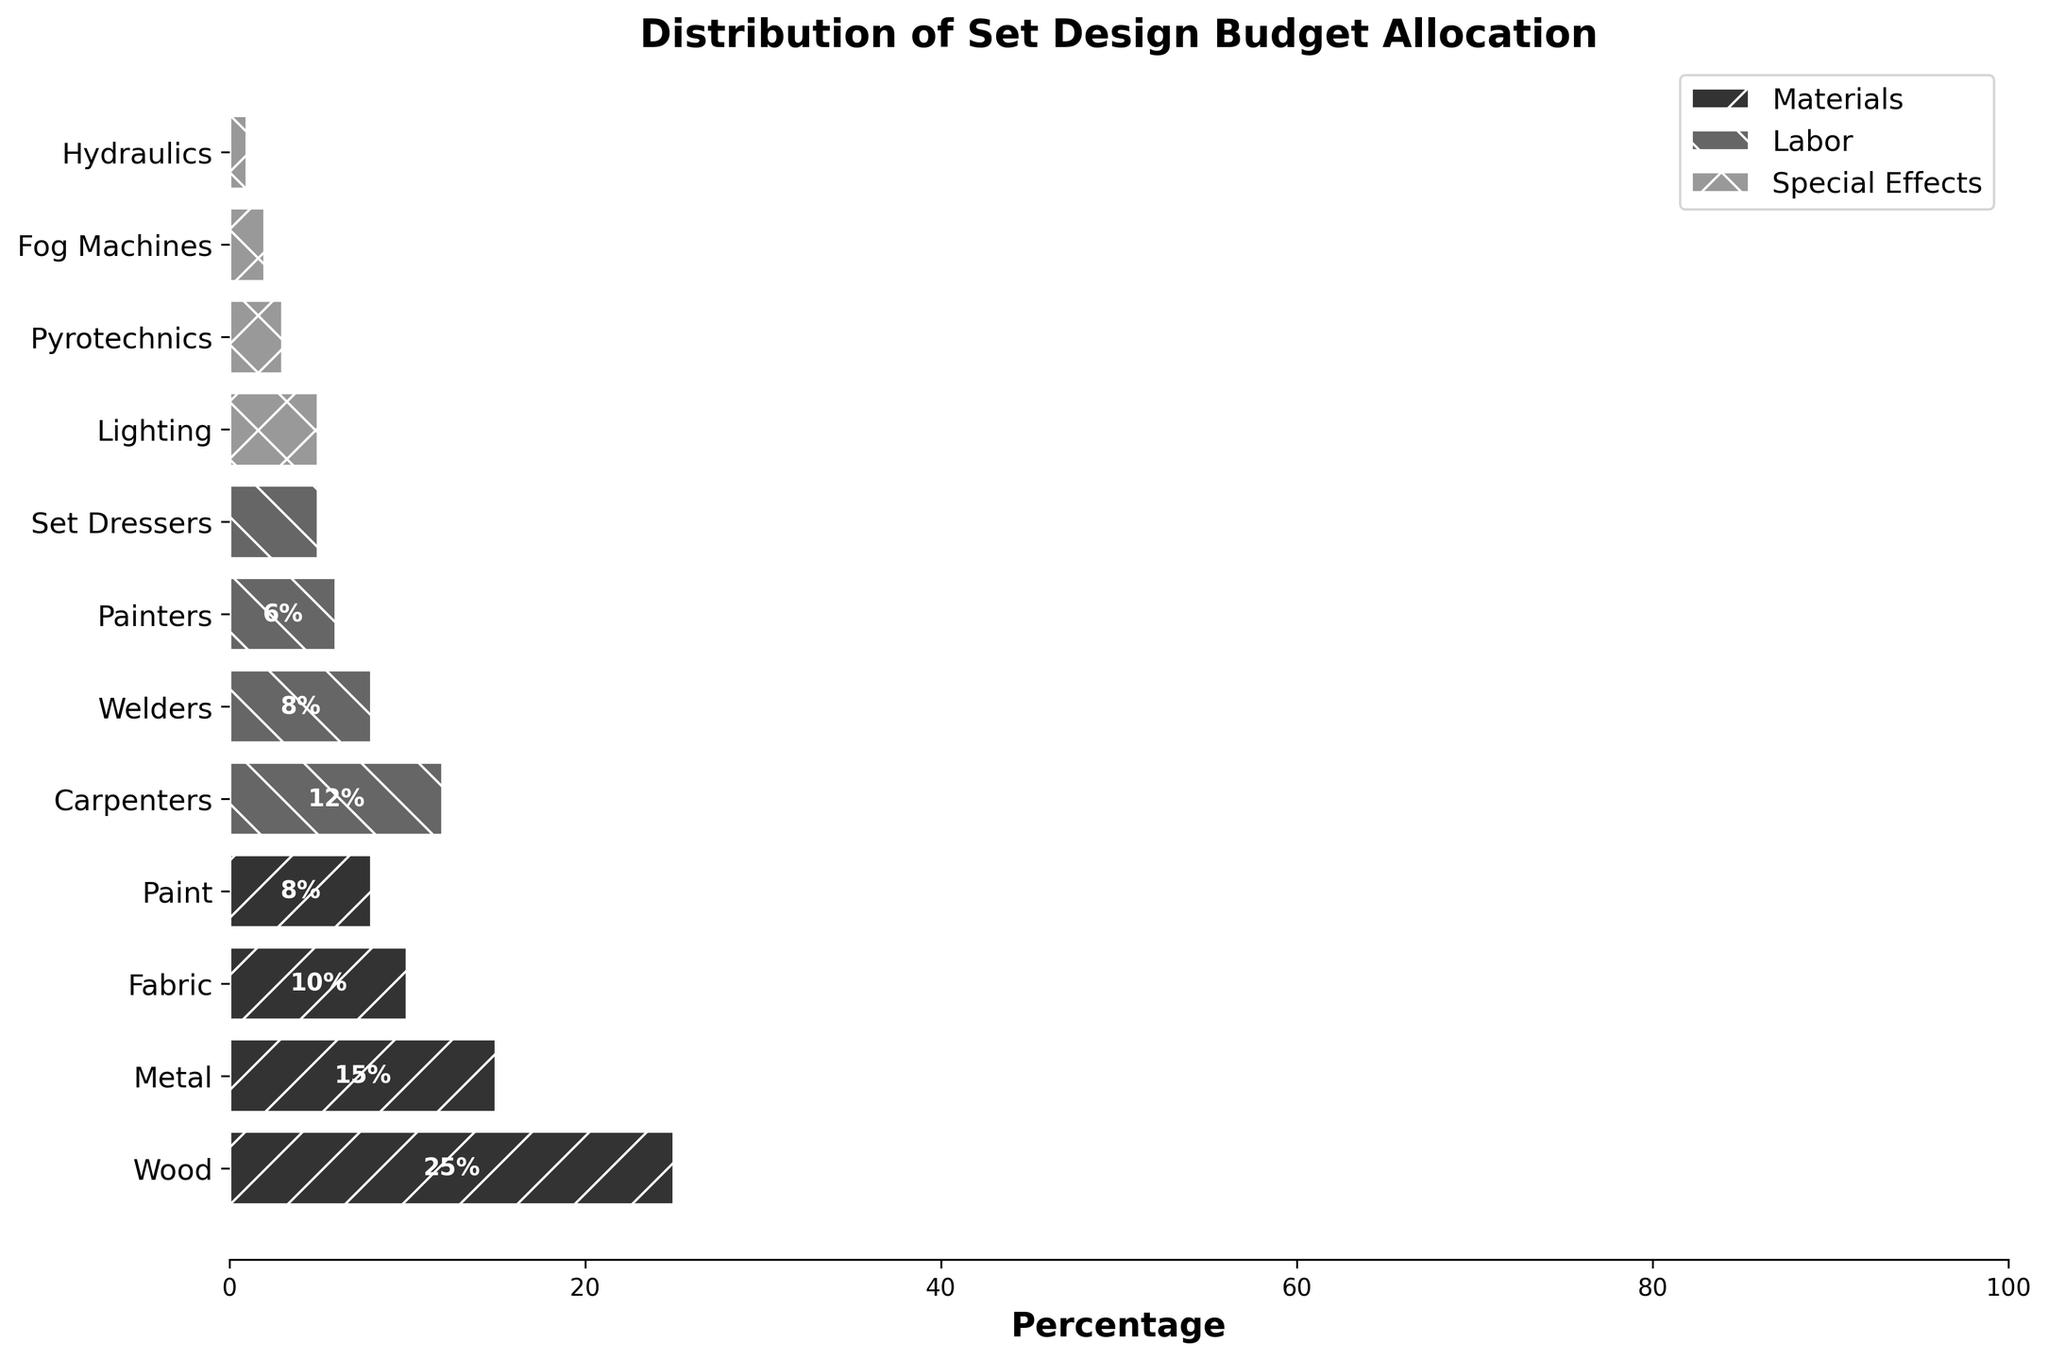What's the main focus of the figure? The title of the figure "Distribution of Set Design Budget Allocation" indicates that it depicts the breakdown of the budget across various elements in set design.
Answer: Distribution of Set Design Budget Allocation How many elements are represented in the Special Effects category? Observing the legend for the Special Effects category and counting the individual elements within the corresponding parts of the plot reveals four distinct elements.
Answer: 4 Which element has the highest percentage allocation? By comparing the heights of the bars, we can see that Wood, which falls under the Materials category, has the longest bar, indicating the highest allocation at 25%.
Answer: Wood What's the total percentage allocation for labor-related elements? Summing up the percentages for Carpenters (12%), Welders (8%), Painters (6%), and Set Dressers (5%) gives a total of 31%.
Answer: 31% Which has a higher budget allocation: Metal or Carpenters? Comparing the bars for Metal (15%) and Carpenters (12%) directly shows that Metal has a higher percentage allocation.
Answer: Metal What is the combined budget percentage for Paint and Set Dressers? Adding the contributions of Paint (8%) and Set Dressers (5%) results in a total of 13%.
Answer: 13% How does the allocation for Lighting compare to the allocation for Fabric? The plot shows Lighting at 5% and Fabric at 10%, illustrating that Fabric has a higher budget allocation than Lighting.
Answer: Fabric What percentage of the budget is allocated to hydraulics? Observing the portion of the bar representing Hydraulics reveals it is 1% of the budget.
Answer: 1% What's the difference in budget allocation between Paint and Pyrotechnics? By referencing Paint's 8% allocation and Pyrotechnics' 3% allocation, the difference is calculated as 5%.
Answer: 5% What pattern is used for the Materials category in the plot? The Materials elements are represented using a specific pattern which, according to the legend, is identified by a slash ("/") pattern across the bars.
Answer: Slash pattern 